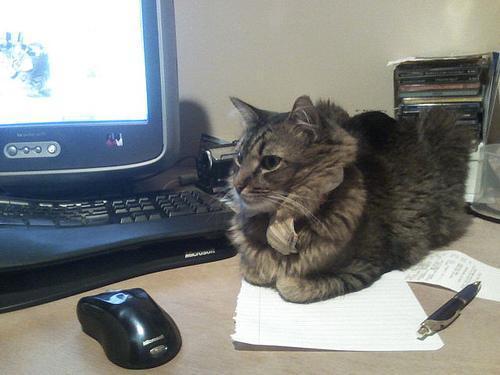How many cats are in this picture?
Give a very brief answer. 1. 